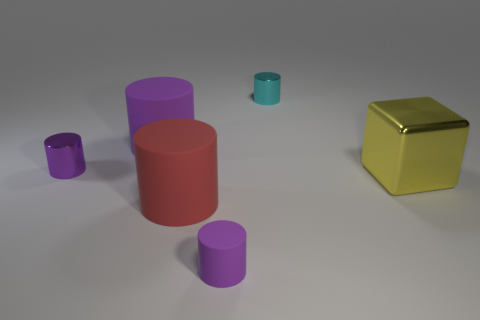Subtract all purple cylinders. How many were subtracted if there are1purple cylinders left? 2 Subtract all tiny purple metallic cylinders. How many cylinders are left? 4 Add 4 cyan cylinders. How many objects exist? 10 Subtract all green balls. How many purple cylinders are left? 3 Subtract all red cylinders. How many cylinders are left? 4 Subtract 1 cylinders. How many cylinders are left? 4 Subtract 2 purple cylinders. How many objects are left? 4 Subtract all cylinders. How many objects are left? 1 Subtract all blue blocks. Subtract all green spheres. How many blocks are left? 1 Subtract all big yellow blocks. Subtract all large red cylinders. How many objects are left? 4 